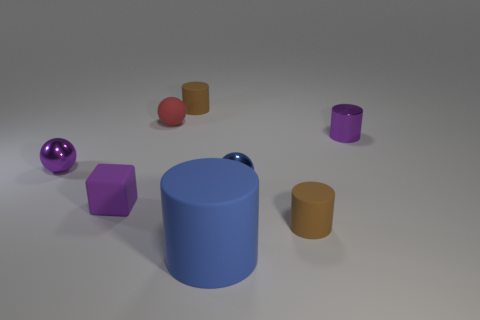Add 1 big purple shiny balls. How many objects exist? 9 Subtract all blue cylinders. How many cylinders are left? 3 Subtract all tiny blue balls. How many balls are left? 2 Subtract all spheres. How many objects are left? 5 Subtract 2 spheres. How many spheres are left? 1 Subtract all gray cylinders. Subtract all green blocks. How many cylinders are left? 4 Subtract all blue cubes. How many purple balls are left? 1 Subtract all blue metallic spheres. Subtract all matte objects. How many objects are left? 2 Add 2 big blue objects. How many big blue objects are left? 3 Add 4 tiny red rubber balls. How many tiny red rubber balls exist? 5 